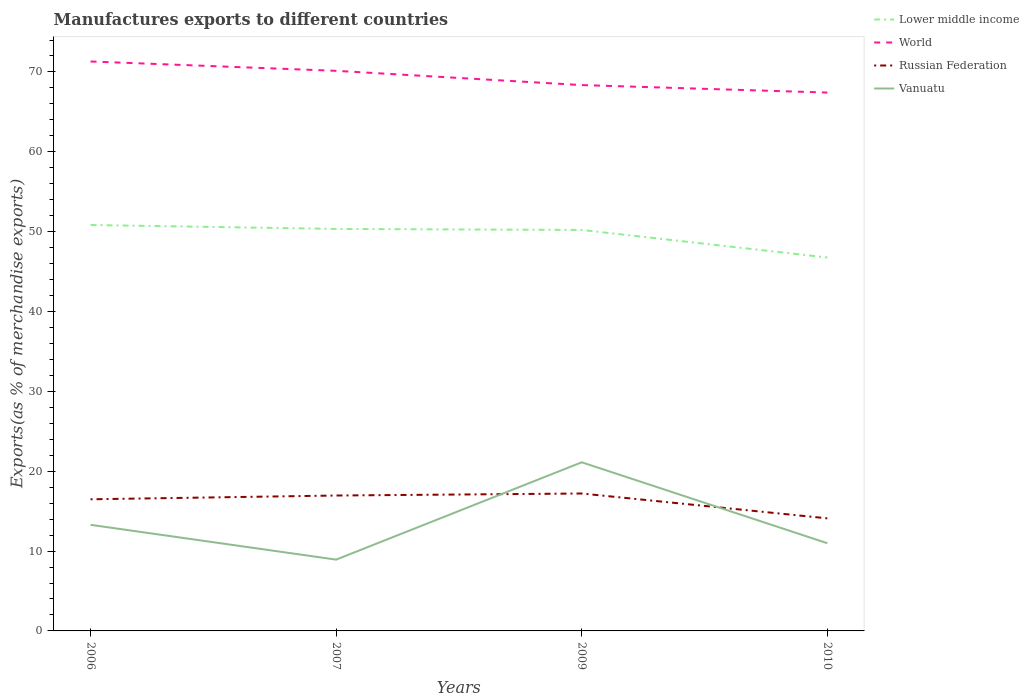How many different coloured lines are there?
Your response must be concise. 4. Does the line corresponding to Lower middle income intersect with the line corresponding to World?
Provide a short and direct response. No. Across all years, what is the maximum percentage of exports to different countries in World?
Your response must be concise. 67.42. What is the total percentage of exports to different countries in Russian Federation in the graph?
Offer a very short reply. -0.47. What is the difference between the highest and the second highest percentage of exports to different countries in Lower middle income?
Provide a succinct answer. 4.07. What is the difference between the highest and the lowest percentage of exports to different countries in Lower middle income?
Offer a very short reply. 3. Is the percentage of exports to different countries in Vanuatu strictly greater than the percentage of exports to different countries in World over the years?
Provide a succinct answer. Yes. How many lines are there?
Ensure brevity in your answer.  4. Does the graph contain any zero values?
Your response must be concise. No. Does the graph contain grids?
Your answer should be compact. No. Where does the legend appear in the graph?
Provide a succinct answer. Top right. How many legend labels are there?
Your response must be concise. 4. What is the title of the graph?
Provide a short and direct response. Manufactures exports to different countries. What is the label or title of the Y-axis?
Your response must be concise. Exports(as % of merchandise exports). What is the Exports(as % of merchandise exports) in Lower middle income in 2006?
Offer a terse response. 50.83. What is the Exports(as % of merchandise exports) in World in 2006?
Keep it short and to the point. 71.31. What is the Exports(as % of merchandise exports) in Russian Federation in 2006?
Provide a short and direct response. 16.48. What is the Exports(as % of merchandise exports) of Vanuatu in 2006?
Your response must be concise. 13.29. What is the Exports(as % of merchandise exports) in Lower middle income in 2007?
Make the answer very short. 50.34. What is the Exports(as % of merchandise exports) of World in 2007?
Keep it short and to the point. 70.14. What is the Exports(as % of merchandise exports) in Russian Federation in 2007?
Keep it short and to the point. 16.96. What is the Exports(as % of merchandise exports) in Vanuatu in 2007?
Your answer should be very brief. 8.93. What is the Exports(as % of merchandise exports) of Lower middle income in 2009?
Make the answer very short. 50.21. What is the Exports(as % of merchandise exports) of World in 2009?
Ensure brevity in your answer.  68.36. What is the Exports(as % of merchandise exports) of Russian Federation in 2009?
Offer a very short reply. 17.21. What is the Exports(as % of merchandise exports) of Vanuatu in 2009?
Make the answer very short. 21.12. What is the Exports(as % of merchandise exports) in Lower middle income in 2010?
Provide a short and direct response. 46.76. What is the Exports(as % of merchandise exports) of World in 2010?
Offer a terse response. 67.42. What is the Exports(as % of merchandise exports) in Russian Federation in 2010?
Make the answer very short. 14.1. What is the Exports(as % of merchandise exports) of Vanuatu in 2010?
Give a very brief answer. 10.98. Across all years, what is the maximum Exports(as % of merchandise exports) in Lower middle income?
Make the answer very short. 50.83. Across all years, what is the maximum Exports(as % of merchandise exports) of World?
Ensure brevity in your answer.  71.31. Across all years, what is the maximum Exports(as % of merchandise exports) of Russian Federation?
Your response must be concise. 17.21. Across all years, what is the maximum Exports(as % of merchandise exports) of Vanuatu?
Give a very brief answer. 21.12. Across all years, what is the minimum Exports(as % of merchandise exports) in Lower middle income?
Ensure brevity in your answer.  46.76. Across all years, what is the minimum Exports(as % of merchandise exports) in World?
Your answer should be very brief. 67.42. Across all years, what is the minimum Exports(as % of merchandise exports) in Russian Federation?
Provide a short and direct response. 14.1. Across all years, what is the minimum Exports(as % of merchandise exports) of Vanuatu?
Make the answer very short. 8.93. What is the total Exports(as % of merchandise exports) in Lower middle income in the graph?
Make the answer very short. 198.15. What is the total Exports(as % of merchandise exports) in World in the graph?
Provide a short and direct response. 277.23. What is the total Exports(as % of merchandise exports) in Russian Federation in the graph?
Your answer should be very brief. 64.75. What is the total Exports(as % of merchandise exports) of Vanuatu in the graph?
Keep it short and to the point. 54.32. What is the difference between the Exports(as % of merchandise exports) of Lower middle income in 2006 and that in 2007?
Give a very brief answer. 0.49. What is the difference between the Exports(as % of merchandise exports) in World in 2006 and that in 2007?
Your answer should be very brief. 1.17. What is the difference between the Exports(as % of merchandise exports) of Russian Federation in 2006 and that in 2007?
Make the answer very short. -0.47. What is the difference between the Exports(as % of merchandise exports) in Vanuatu in 2006 and that in 2007?
Give a very brief answer. 4.36. What is the difference between the Exports(as % of merchandise exports) of Lower middle income in 2006 and that in 2009?
Your answer should be very brief. 0.62. What is the difference between the Exports(as % of merchandise exports) of World in 2006 and that in 2009?
Offer a terse response. 2.96. What is the difference between the Exports(as % of merchandise exports) in Russian Federation in 2006 and that in 2009?
Make the answer very short. -0.72. What is the difference between the Exports(as % of merchandise exports) of Vanuatu in 2006 and that in 2009?
Offer a terse response. -7.83. What is the difference between the Exports(as % of merchandise exports) of Lower middle income in 2006 and that in 2010?
Your answer should be very brief. 4.07. What is the difference between the Exports(as % of merchandise exports) of World in 2006 and that in 2010?
Keep it short and to the point. 3.89. What is the difference between the Exports(as % of merchandise exports) of Russian Federation in 2006 and that in 2010?
Your response must be concise. 2.39. What is the difference between the Exports(as % of merchandise exports) in Vanuatu in 2006 and that in 2010?
Give a very brief answer. 2.3. What is the difference between the Exports(as % of merchandise exports) of Lower middle income in 2007 and that in 2009?
Ensure brevity in your answer.  0.13. What is the difference between the Exports(as % of merchandise exports) in World in 2007 and that in 2009?
Keep it short and to the point. 1.79. What is the difference between the Exports(as % of merchandise exports) in Russian Federation in 2007 and that in 2009?
Your answer should be compact. -0.25. What is the difference between the Exports(as % of merchandise exports) in Vanuatu in 2007 and that in 2009?
Provide a short and direct response. -12.19. What is the difference between the Exports(as % of merchandise exports) of Lower middle income in 2007 and that in 2010?
Give a very brief answer. 3.58. What is the difference between the Exports(as % of merchandise exports) in World in 2007 and that in 2010?
Provide a short and direct response. 2.72. What is the difference between the Exports(as % of merchandise exports) of Russian Federation in 2007 and that in 2010?
Offer a terse response. 2.86. What is the difference between the Exports(as % of merchandise exports) in Vanuatu in 2007 and that in 2010?
Keep it short and to the point. -2.05. What is the difference between the Exports(as % of merchandise exports) in Lower middle income in 2009 and that in 2010?
Offer a terse response. 3.45. What is the difference between the Exports(as % of merchandise exports) in World in 2009 and that in 2010?
Make the answer very short. 0.94. What is the difference between the Exports(as % of merchandise exports) of Russian Federation in 2009 and that in 2010?
Keep it short and to the point. 3.11. What is the difference between the Exports(as % of merchandise exports) of Vanuatu in 2009 and that in 2010?
Ensure brevity in your answer.  10.13. What is the difference between the Exports(as % of merchandise exports) in Lower middle income in 2006 and the Exports(as % of merchandise exports) in World in 2007?
Provide a succinct answer. -19.31. What is the difference between the Exports(as % of merchandise exports) of Lower middle income in 2006 and the Exports(as % of merchandise exports) of Russian Federation in 2007?
Your answer should be compact. 33.88. What is the difference between the Exports(as % of merchandise exports) in Lower middle income in 2006 and the Exports(as % of merchandise exports) in Vanuatu in 2007?
Keep it short and to the point. 41.9. What is the difference between the Exports(as % of merchandise exports) in World in 2006 and the Exports(as % of merchandise exports) in Russian Federation in 2007?
Provide a succinct answer. 54.35. What is the difference between the Exports(as % of merchandise exports) in World in 2006 and the Exports(as % of merchandise exports) in Vanuatu in 2007?
Your answer should be compact. 62.38. What is the difference between the Exports(as % of merchandise exports) in Russian Federation in 2006 and the Exports(as % of merchandise exports) in Vanuatu in 2007?
Your answer should be compact. 7.56. What is the difference between the Exports(as % of merchandise exports) in Lower middle income in 2006 and the Exports(as % of merchandise exports) in World in 2009?
Make the answer very short. -17.52. What is the difference between the Exports(as % of merchandise exports) in Lower middle income in 2006 and the Exports(as % of merchandise exports) in Russian Federation in 2009?
Your response must be concise. 33.62. What is the difference between the Exports(as % of merchandise exports) of Lower middle income in 2006 and the Exports(as % of merchandise exports) of Vanuatu in 2009?
Offer a terse response. 29.72. What is the difference between the Exports(as % of merchandise exports) in World in 2006 and the Exports(as % of merchandise exports) in Russian Federation in 2009?
Your answer should be very brief. 54.1. What is the difference between the Exports(as % of merchandise exports) in World in 2006 and the Exports(as % of merchandise exports) in Vanuatu in 2009?
Provide a succinct answer. 50.19. What is the difference between the Exports(as % of merchandise exports) in Russian Federation in 2006 and the Exports(as % of merchandise exports) in Vanuatu in 2009?
Offer a very short reply. -4.63. What is the difference between the Exports(as % of merchandise exports) in Lower middle income in 2006 and the Exports(as % of merchandise exports) in World in 2010?
Your answer should be very brief. -16.59. What is the difference between the Exports(as % of merchandise exports) in Lower middle income in 2006 and the Exports(as % of merchandise exports) in Russian Federation in 2010?
Offer a terse response. 36.74. What is the difference between the Exports(as % of merchandise exports) of Lower middle income in 2006 and the Exports(as % of merchandise exports) of Vanuatu in 2010?
Keep it short and to the point. 39.85. What is the difference between the Exports(as % of merchandise exports) of World in 2006 and the Exports(as % of merchandise exports) of Russian Federation in 2010?
Offer a terse response. 57.21. What is the difference between the Exports(as % of merchandise exports) in World in 2006 and the Exports(as % of merchandise exports) in Vanuatu in 2010?
Make the answer very short. 60.33. What is the difference between the Exports(as % of merchandise exports) of Russian Federation in 2006 and the Exports(as % of merchandise exports) of Vanuatu in 2010?
Provide a succinct answer. 5.5. What is the difference between the Exports(as % of merchandise exports) in Lower middle income in 2007 and the Exports(as % of merchandise exports) in World in 2009?
Your answer should be very brief. -18.01. What is the difference between the Exports(as % of merchandise exports) of Lower middle income in 2007 and the Exports(as % of merchandise exports) of Russian Federation in 2009?
Ensure brevity in your answer.  33.13. What is the difference between the Exports(as % of merchandise exports) of Lower middle income in 2007 and the Exports(as % of merchandise exports) of Vanuatu in 2009?
Your answer should be very brief. 29.22. What is the difference between the Exports(as % of merchandise exports) in World in 2007 and the Exports(as % of merchandise exports) in Russian Federation in 2009?
Offer a very short reply. 52.93. What is the difference between the Exports(as % of merchandise exports) of World in 2007 and the Exports(as % of merchandise exports) of Vanuatu in 2009?
Offer a terse response. 49.02. What is the difference between the Exports(as % of merchandise exports) of Russian Federation in 2007 and the Exports(as % of merchandise exports) of Vanuatu in 2009?
Your answer should be very brief. -4.16. What is the difference between the Exports(as % of merchandise exports) of Lower middle income in 2007 and the Exports(as % of merchandise exports) of World in 2010?
Ensure brevity in your answer.  -17.08. What is the difference between the Exports(as % of merchandise exports) of Lower middle income in 2007 and the Exports(as % of merchandise exports) of Russian Federation in 2010?
Keep it short and to the point. 36.24. What is the difference between the Exports(as % of merchandise exports) in Lower middle income in 2007 and the Exports(as % of merchandise exports) in Vanuatu in 2010?
Give a very brief answer. 39.36. What is the difference between the Exports(as % of merchandise exports) in World in 2007 and the Exports(as % of merchandise exports) in Russian Federation in 2010?
Your answer should be very brief. 56.04. What is the difference between the Exports(as % of merchandise exports) of World in 2007 and the Exports(as % of merchandise exports) of Vanuatu in 2010?
Your answer should be very brief. 59.16. What is the difference between the Exports(as % of merchandise exports) of Russian Federation in 2007 and the Exports(as % of merchandise exports) of Vanuatu in 2010?
Your answer should be very brief. 5.97. What is the difference between the Exports(as % of merchandise exports) in Lower middle income in 2009 and the Exports(as % of merchandise exports) in World in 2010?
Provide a succinct answer. -17.21. What is the difference between the Exports(as % of merchandise exports) in Lower middle income in 2009 and the Exports(as % of merchandise exports) in Russian Federation in 2010?
Your answer should be very brief. 36.12. What is the difference between the Exports(as % of merchandise exports) in Lower middle income in 2009 and the Exports(as % of merchandise exports) in Vanuatu in 2010?
Offer a terse response. 39.23. What is the difference between the Exports(as % of merchandise exports) in World in 2009 and the Exports(as % of merchandise exports) in Russian Federation in 2010?
Make the answer very short. 54.26. What is the difference between the Exports(as % of merchandise exports) in World in 2009 and the Exports(as % of merchandise exports) in Vanuatu in 2010?
Your answer should be very brief. 57.37. What is the difference between the Exports(as % of merchandise exports) of Russian Federation in 2009 and the Exports(as % of merchandise exports) of Vanuatu in 2010?
Your response must be concise. 6.22. What is the average Exports(as % of merchandise exports) in Lower middle income per year?
Offer a terse response. 49.54. What is the average Exports(as % of merchandise exports) of World per year?
Your answer should be very brief. 69.31. What is the average Exports(as % of merchandise exports) in Russian Federation per year?
Your answer should be very brief. 16.19. What is the average Exports(as % of merchandise exports) of Vanuatu per year?
Your answer should be compact. 13.58. In the year 2006, what is the difference between the Exports(as % of merchandise exports) in Lower middle income and Exports(as % of merchandise exports) in World?
Provide a succinct answer. -20.48. In the year 2006, what is the difference between the Exports(as % of merchandise exports) in Lower middle income and Exports(as % of merchandise exports) in Russian Federation?
Keep it short and to the point. 34.35. In the year 2006, what is the difference between the Exports(as % of merchandise exports) in Lower middle income and Exports(as % of merchandise exports) in Vanuatu?
Make the answer very short. 37.55. In the year 2006, what is the difference between the Exports(as % of merchandise exports) in World and Exports(as % of merchandise exports) in Russian Federation?
Give a very brief answer. 54.83. In the year 2006, what is the difference between the Exports(as % of merchandise exports) of World and Exports(as % of merchandise exports) of Vanuatu?
Make the answer very short. 58.02. In the year 2006, what is the difference between the Exports(as % of merchandise exports) of Russian Federation and Exports(as % of merchandise exports) of Vanuatu?
Your answer should be compact. 3.2. In the year 2007, what is the difference between the Exports(as % of merchandise exports) in Lower middle income and Exports(as % of merchandise exports) in World?
Offer a very short reply. -19.8. In the year 2007, what is the difference between the Exports(as % of merchandise exports) of Lower middle income and Exports(as % of merchandise exports) of Russian Federation?
Offer a very short reply. 33.39. In the year 2007, what is the difference between the Exports(as % of merchandise exports) of Lower middle income and Exports(as % of merchandise exports) of Vanuatu?
Ensure brevity in your answer.  41.41. In the year 2007, what is the difference between the Exports(as % of merchandise exports) in World and Exports(as % of merchandise exports) in Russian Federation?
Provide a short and direct response. 53.19. In the year 2007, what is the difference between the Exports(as % of merchandise exports) in World and Exports(as % of merchandise exports) in Vanuatu?
Offer a very short reply. 61.21. In the year 2007, what is the difference between the Exports(as % of merchandise exports) of Russian Federation and Exports(as % of merchandise exports) of Vanuatu?
Give a very brief answer. 8.03. In the year 2009, what is the difference between the Exports(as % of merchandise exports) in Lower middle income and Exports(as % of merchandise exports) in World?
Give a very brief answer. -18.14. In the year 2009, what is the difference between the Exports(as % of merchandise exports) in Lower middle income and Exports(as % of merchandise exports) in Russian Federation?
Provide a succinct answer. 33. In the year 2009, what is the difference between the Exports(as % of merchandise exports) in Lower middle income and Exports(as % of merchandise exports) in Vanuatu?
Your response must be concise. 29.09. In the year 2009, what is the difference between the Exports(as % of merchandise exports) in World and Exports(as % of merchandise exports) in Russian Federation?
Ensure brevity in your answer.  51.15. In the year 2009, what is the difference between the Exports(as % of merchandise exports) in World and Exports(as % of merchandise exports) in Vanuatu?
Keep it short and to the point. 47.24. In the year 2009, what is the difference between the Exports(as % of merchandise exports) of Russian Federation and Exports(as % of merchandise exports) of Vanuatu?
Your answer should be very brief. -3.91. In the year 2010, what is the difference between the Exports(as % of merchandise exports) in Lower middle income and Exports(as % of merchandise exports) in World?
Provide a succinct answer. -20.66. In the year 2010, what is the difference between the Exports(as % of merchandise exports) of Lower middle income and Exports(as % of merchandise exports) of Russian Federation?
Make the answer very short. 32.67. In the year 2010, what is the difference between the Exports(as % of merchandise exports) in Lower middle income and Exports(as % of merchandise exports) in Vanuatu?
Provide a short and direct response. 35.78. In the year 2010, what is the difference between the Exports(as % of merchandise exports) in World and Exports(as % of merchandise exports) in Russian Federation?
Provide a short and direct response. 53.32. In the year 2010, what is the difference between the Exports(as % of merchandise exports) of World and Exports(as % of merchandise exports) of Vanuatu?
Provide a succinct answer. 56.44. In the year 2010, what is the difference between the Exports(as % of merchandise exports) in Russian Federation and Exports(as % of merchandise exports) in Vanuatu?
Offer a terse response. 3.11. What is the ratio of the Exports(as % of merchandise exports) in Lower middle income in 2006 to that in 2007?
Ensure brevity in your answer.  1.01. What is the ratio of the Exports(as % of merchandise exports) of World in 2006 to that in 2007?
Your answer should be compact. 1.02. What is the ratio of the Exports(as % of merchandise exports) in Russian Federation in 2006 to that in 2007?
Your answer should be compact. 0.97. What is the ratio of the Exports(as % of merchandise exports) of Vanuatu in 2006 to that in 2007?
Offer a terse response. 1.49. What is the ratio of the Exports(as % of merchandise exports) in Lower middle income in 2006 to that in 2009?
Provide a succinct answer. 1.01. What is the ratio of the Exports(as % of merchandise exports) of World in 2006 to that in 2009?
Offer a very short reply. 1.04. What is the ratio of the Exports(as % of merchandise exports) in Russian Federation in 2006 to that in 2009?
Your answer should be compact. 0.96. What is the ratio of the Exports(as % of merchandise exports) in Vanuatu in 2006 to that in 2009?
Make the answer very short. 0.63. What is the ratio of the Exports(as % of merchandise exports) in Lower middle income in 2006 to that in 2010?
Make the answer very short. 1.09. What is the ratio of the Exports(as % of merchandise exports) of World in 2006 to that in 2010?
Your answer should be very brief. 1.06. What is the ratio of the Exports(as % of merchandise exports) in Russian Federation in 2006 to that in 2010?
Your answer should be very brief. 1.17. What is the ratio of the Exports(as % of merchandise exports) of Vanuatu in 2006 to that in 2010?
Provide a short and direct response. 1.21. What is the ratio of the Exports(as % of merchandise exports) of Lower middle income in 2007 to that in 2009?
Keep it short and to the point. 1. What is the ratio of the Exports(as % of merchandise exports) of World in 2007 to that in 2009?
Your response must be concise. 1.03. What is the ratio of the Exports(as % of merchandise exports) in Russian Federation in 2007 to that in 2009?
Provide a short and direct response. 0.99. What is the ratio of the Exports(as % of merchandise exports) in Vanuatu in 2007 to that in 2009?
Offer a terse response. 0.42. What is the ratio of the Exports(as % of merchandise exports) in Lower middle income in 2007 to that in 2010?
Offer a very short reply. 1.08. What is the ratio of the Exports(as % of merchandise exports) of World in 2007 to that in 2010?
Your response must be concise. 1.04. What is the ratio of the Exports(as % of merchandise exports) in Russian Federation in 2007 to that in 2010?
Ensure brevity in your answer.  1.2. What is the ratio of the Exports(as % of merchandise exports) in Vanuatu in 2007 to that in 2010?
Offer a very short reply. 0.81. What is the ratio of the Exports(as % of merchandise exports) in Lower middle income in 2009 to that in 2010?
Your answer should be compact. 1.07. What is the ratio of the Exports(as % of merchandise exports) in World in 2009 to that in 2010?
Give a very brief answer. 1.01. What is the ratio of the Exports(as % of merchandise exports) in Russian Federation in 2009 to that in 2010?
Offer a terse response. 1.22. What is the ratio of the Exports(as % of merchandise exports) in Vanuatu in 2009 to that in 2010?
Provide a succinct answer. 1.92. What is the difference between the highest and the second highest Exports(as % of merchandise exports) in Lower middle income?
Your answer should be very brief. 0.49. What is the difference between the highest and the second highest Exports(as % of merchandise exports) in World?
Make the answer very short. 1.17. What is the difference between the highest and the second highest Exports(as % of merchandise exports) of Russian Federation?
Give a very brief answer. 0.25. What is the difference between the highest and the second highest Exports(as % of merchandise exports) of Vanuatu?
Your response must be concise. 7.83. What is the difference between the highest and the lowest Exports(as % of merchandise exports) of Lower middle income?
Give a very brief answer. 4.07. What is the difference between the highest and the lowest Exports(as % of merchandise exports) of World?
Your answer should be compact. 3.89. What is the difference between the highest and the lowest Exports(as % of merchandise exports) of Russian Federation?
Ensure brevity in your answer.  3.11. What is the difference between the highest and the lowest Exports(as % of merchandise exports) in Vanuatu?
Provide a succinct answer. 12.19. 